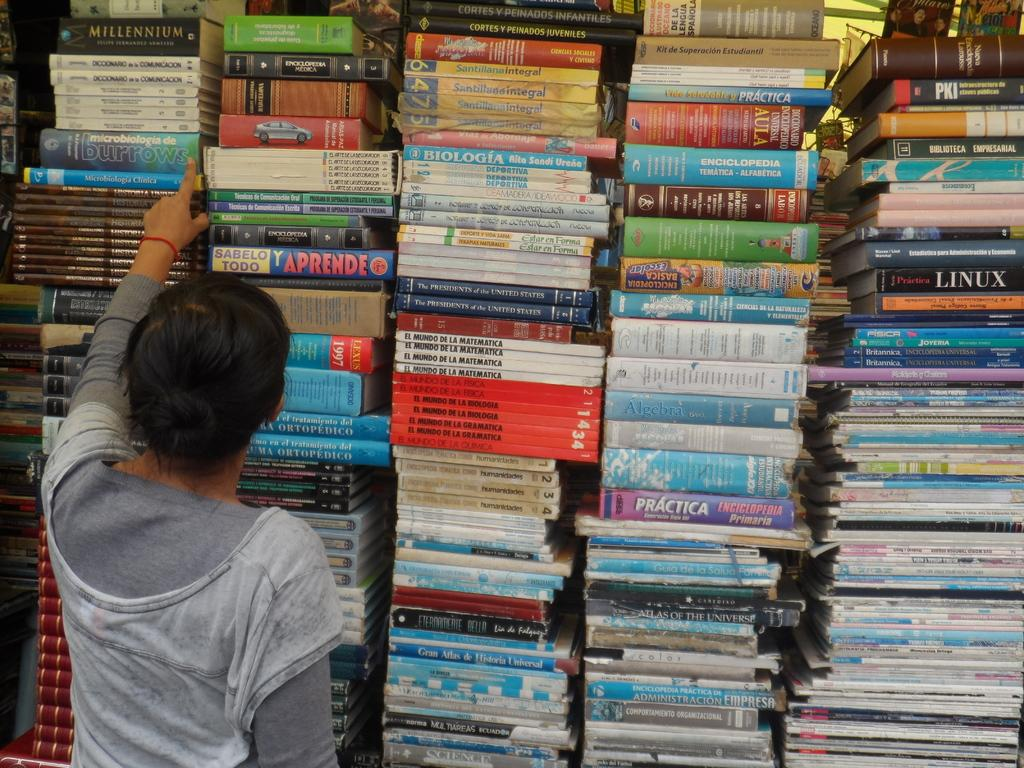<image>
Share a concise interpretation of the image provided. A woman looks through a wall of books with titles like Aprende and Practica. 